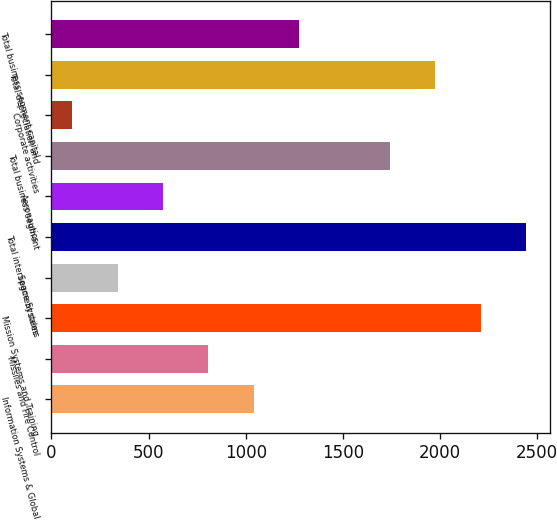Convert chart. <chart><loc_0><loc_0><loc_500><loc_500><bar_chart><fcel>Information Systems & Global<fcel>Missiles and Fire Control<fcel>Mission Systems and Training<fcel>Space Systems<fcel>Total intersegment sales<fcel>Aeronautics<fcel>Total business segment<fcel>Corporate activities<fcel>Total depreciation and<fcel>Total business segment capital<nl><fcel>1041.4<fcel>807.8<fcel>2209.4<fcel>340.6<fcel>2443<fcel>574.2<fcel>1742.2<fcel>107<fcel>1975.8<fcel>1275<nl></chart> 